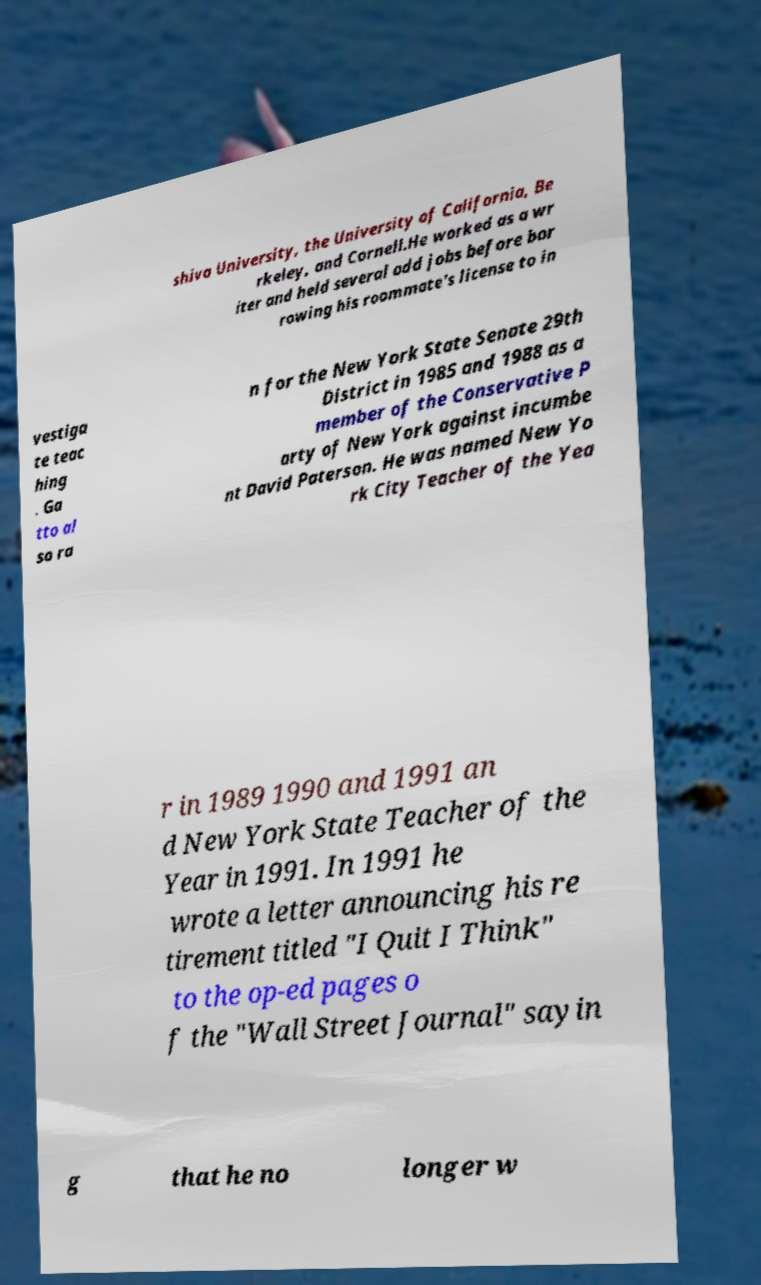Please read and relay the text visible in this image. What does it say? shiva University, the University of California, Be rkeley, and Cornell.He worked as a wr iter and held several odd jobs before bor rowing his roommate's license to in vestiga te teac hing . Ga tto al so ra n for the New York State Senate 29th District in 1985 and 1988 as a member of the Conservative P arty of New York against incumbe nt David Paterson. He was named New Yo rk City Teacher of the Yea r in 1989 1990 and 1991 an d New York State Teacher of the Year in 1991. In 1991 he wrote a letter announcing his re tirement titled "I Quit I Think" to the op-ed pages o f the "Wall Street Journal" sayin g that he no longer w 